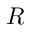<formula> <loc_0><loc_0><loc_500><loc_500>R</formula> 